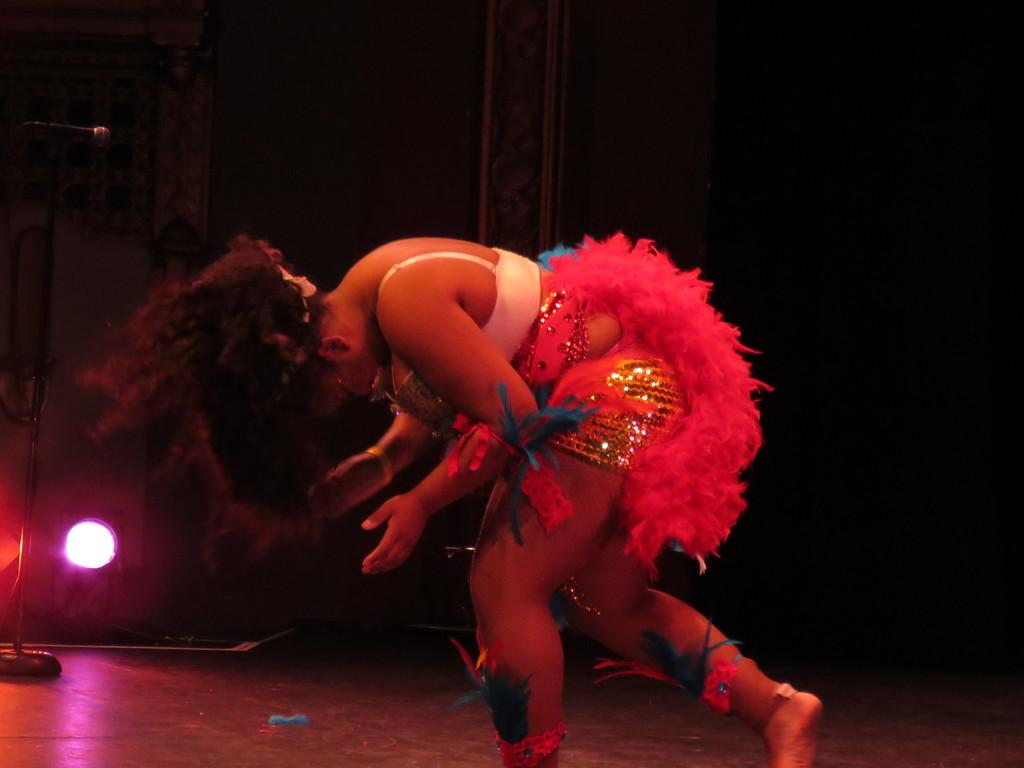Who is the main subject in the image? There is a woman standing in the middle of the image. What can be observed about the background of the image? The background is dark. Is there any source of illumination in the image? Yes, there is a light present in the image. Can you identify any other person in the image besides the woman? Yes, there is a person named Mike on the left side of the image. What type of bat can be seen flying in the garden in the image? There is no bat or garden present in the image; it features a woman, a dark background, and a light source. 